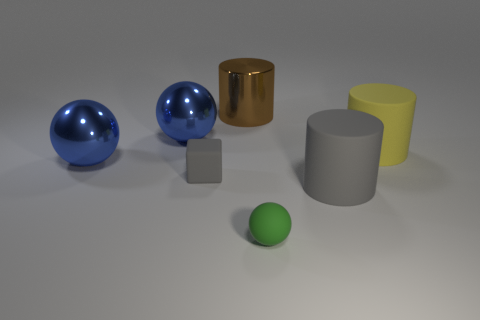What is the material of the cylinder that is the same color as the matte block?
Your answer should be compact. Rubber. Do the yellow cylinder and the cube have the same material?
Your response must be concise. Yes. How many other things are there of the same color as the big shiny cylinder?
Your response must be concise. 0. There is a tiny rubber object that is in front of the large gray cylinder; what is its shape?
Your answer should be very brief. Sphere. How many things are either gray cylinders or large brown objects?
Provide a succinct answer. 2. There is a shiny cylinder; is its size the same as the object in front of the gray rubber cylinder?
Provide a succinct answer. No. How many other objects are the same material as the large yellow cylinder?
Offer a terse response. 3. What number of things are either tiny things to the left of the tiny green rubber thing or tiny rubber objects that are behind the small green rubber sphere?
Provide a succinct answer. 1. There is a large gray thing that is the same shape as the brown object; what is it made of?
Keep it short and to the point. Rubber. Is there a tiny green matte cube?
Offer a terse response. No. 